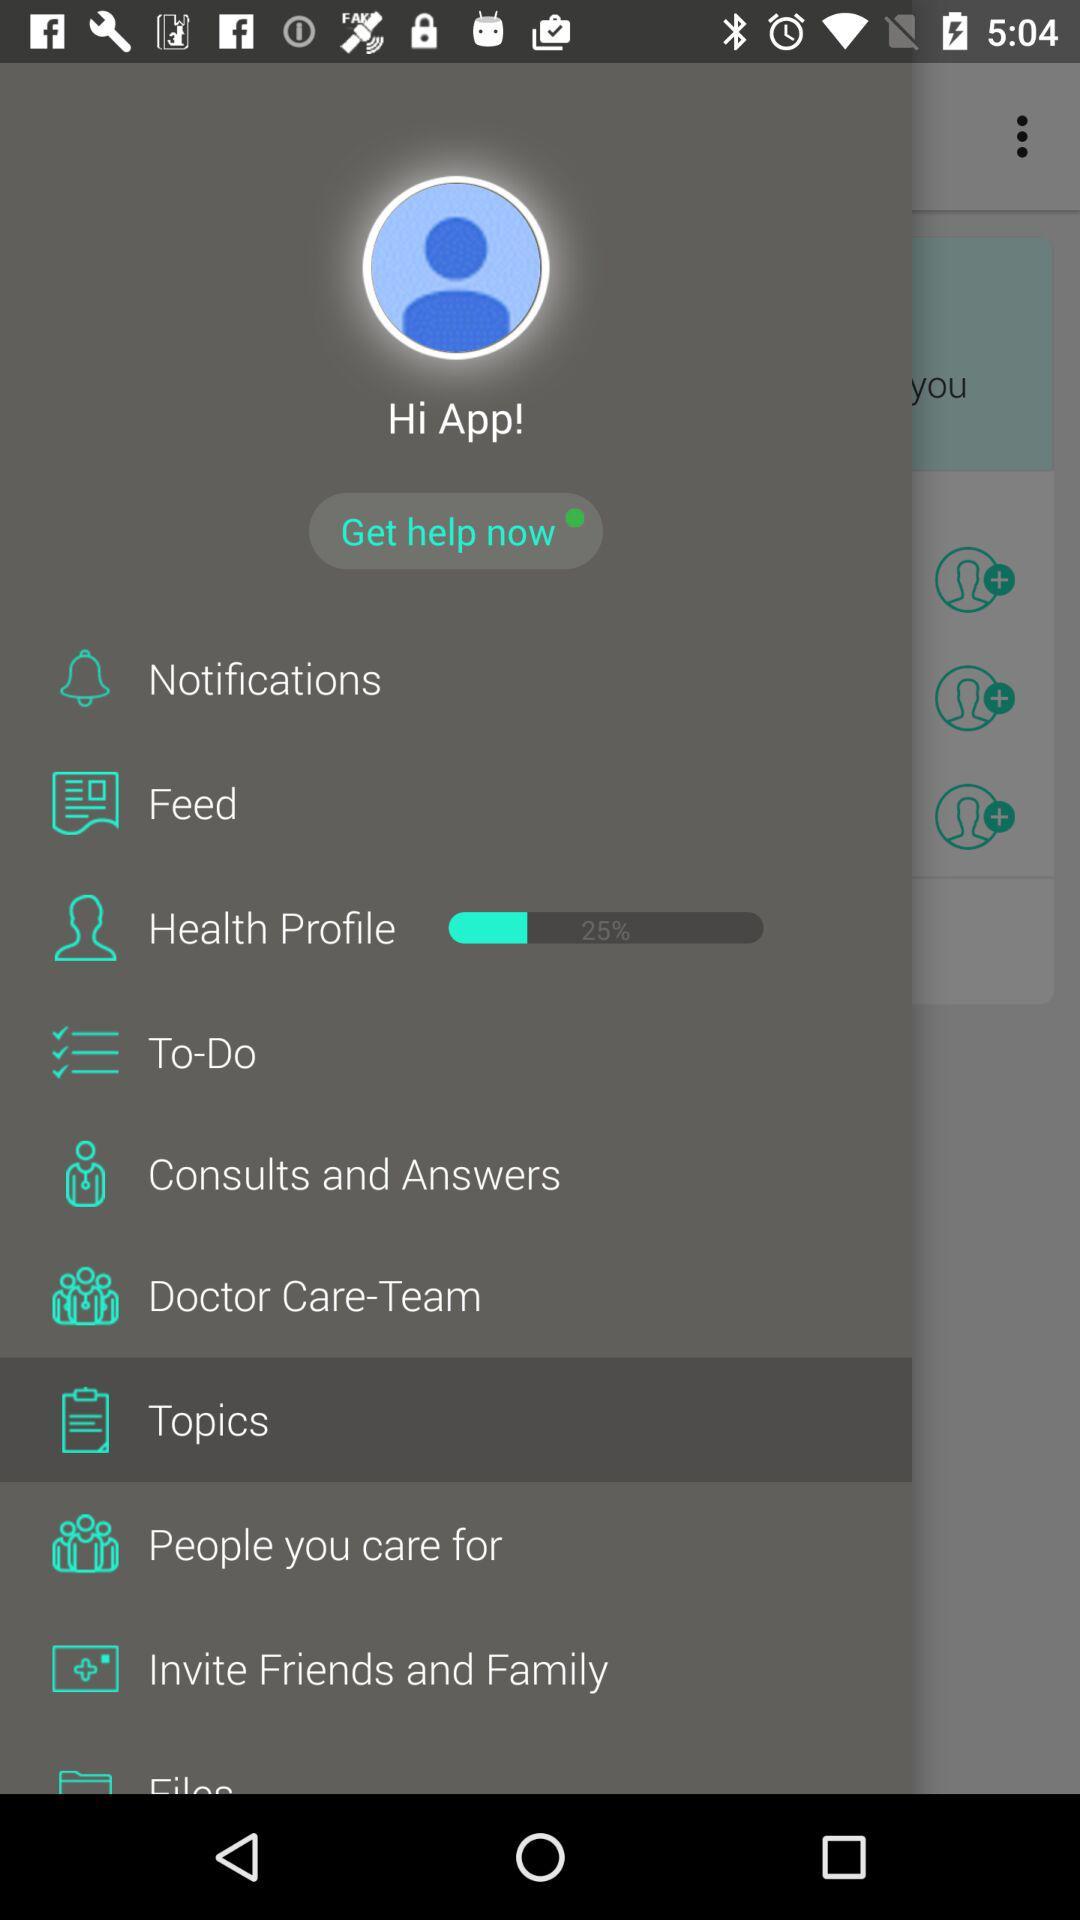What is the selected item? The selected item is "Topics". 